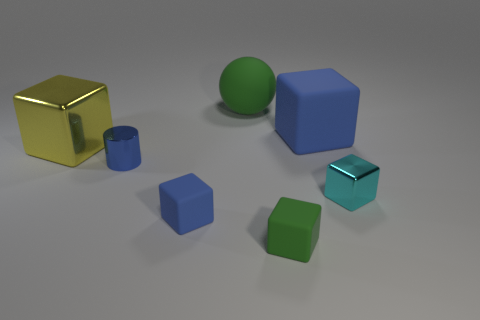The cyan thing that is the same size as the metallic cylinder is what shape?
Provide a short and direct response. Cube. How many cyan objects are either tiny things or big balls?
Give a very brief answer. 1. How many cyan metal objects are the same size as the cylinder?
Offer a terse response. 1. What shape is the rubber thing that is the same color as the sphere?
Provide a succinct answer. Cube. How many objects are large blue blocks or tiny cubes that are on the right side of the large rubber ball?
Provide a short and direct response. 3. There is a blue block that is on the left side of the tiny green cube; is it the same size as the blue cube that is behind the small cyan shiny block?
Make the answer very short. No. What number of blue rubber objects are the same shape as the big green object?
Provide a succinct answer. 0. The blue object that is the same material as the tiny blue block is what shape?
Offer a terse response. Cube. What is the material of the blue block in front of the tiny metallic object that is behind the metallic object that is in front of the blue cylinder?
Offer a very short reply. Rubber. Does the metal cylinder have the same size as the metal cube behind the tiny cyan metal object?
Your answer should be very brief. No. 